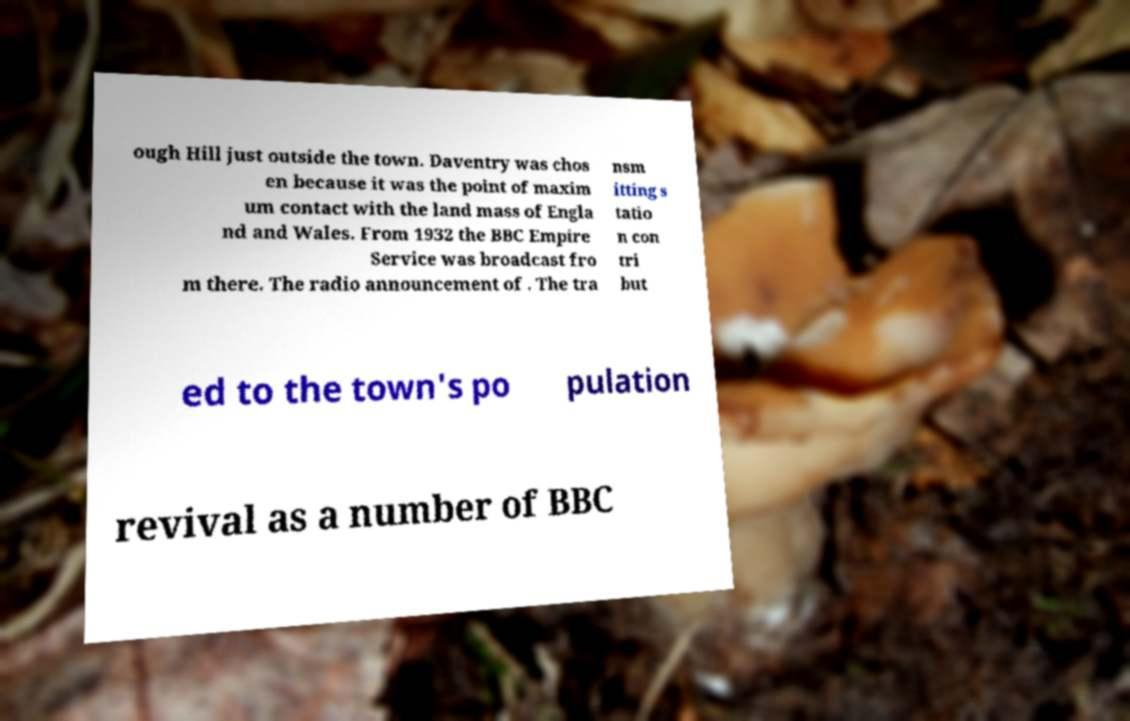Can you read and provide the text displayed in the image?This photo seems to have some interesting text. Can you extract and type it out for me? ough Hill just outside the town. Daventry was chos en because it was the point of maxim um contact with the land mass of Engla nd and Wales. From 1932 the BBC Empire Service was broadcast fro m there. The radio announcement of . The tra nsm itting s tatio n con tri but ed to the town's po pulation revival as a number of BBC 